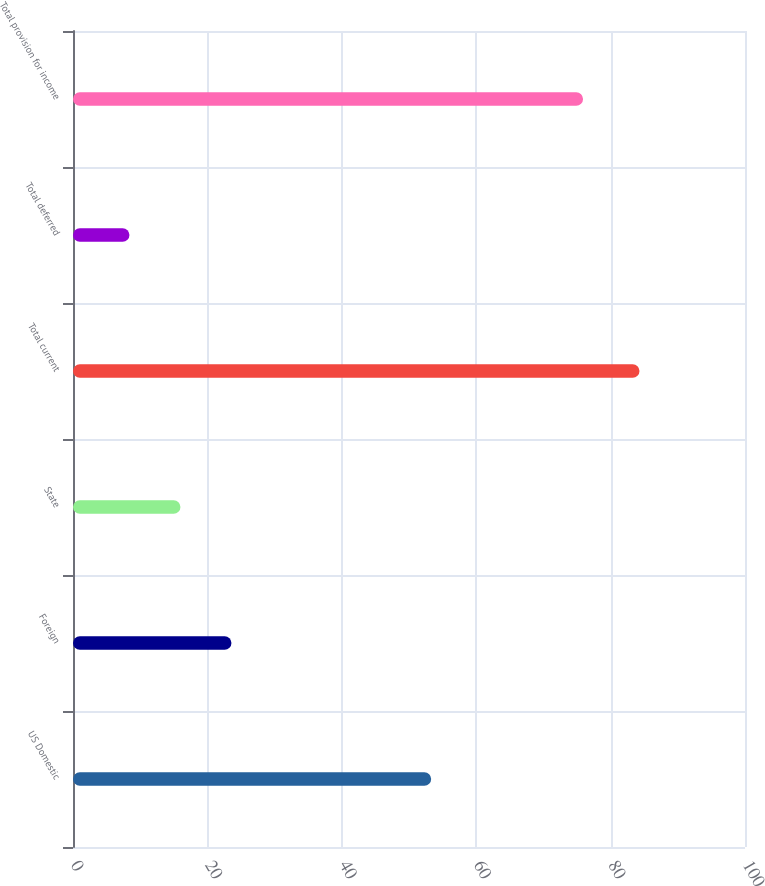Convert chart. <chart><loc_0><loc_0><loc_500><loc_500><bar_chart><fcel>US Domestic<fcel>Foreign<fcel>State<fcel>Total current<fcel>Total deferred<fcel>Total provision for income<nl><fcel>53.3<fcel>23.58<fcel>15.99<fcel>84.3<fcel>8.4<fcel>75.9<nl></chart> 